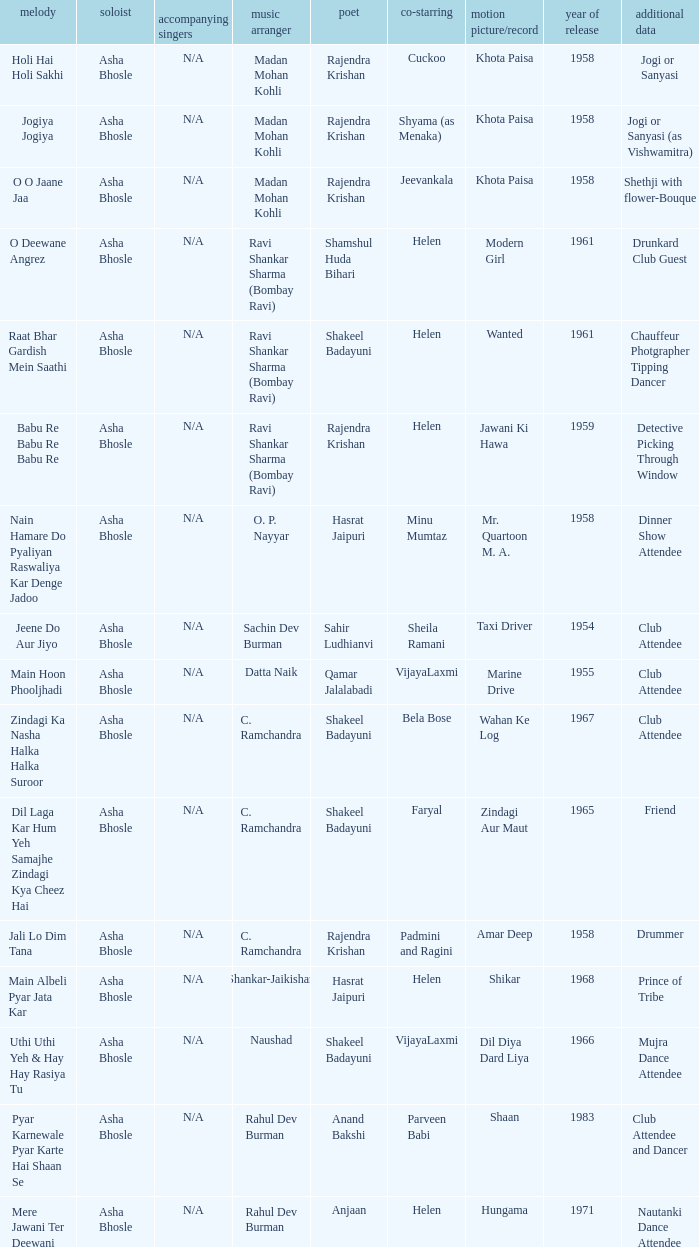What movie did Vijayalaxmi Co-star in and Shakeel Badayuni write the lyrics? Dil Diya Dard Liya. 